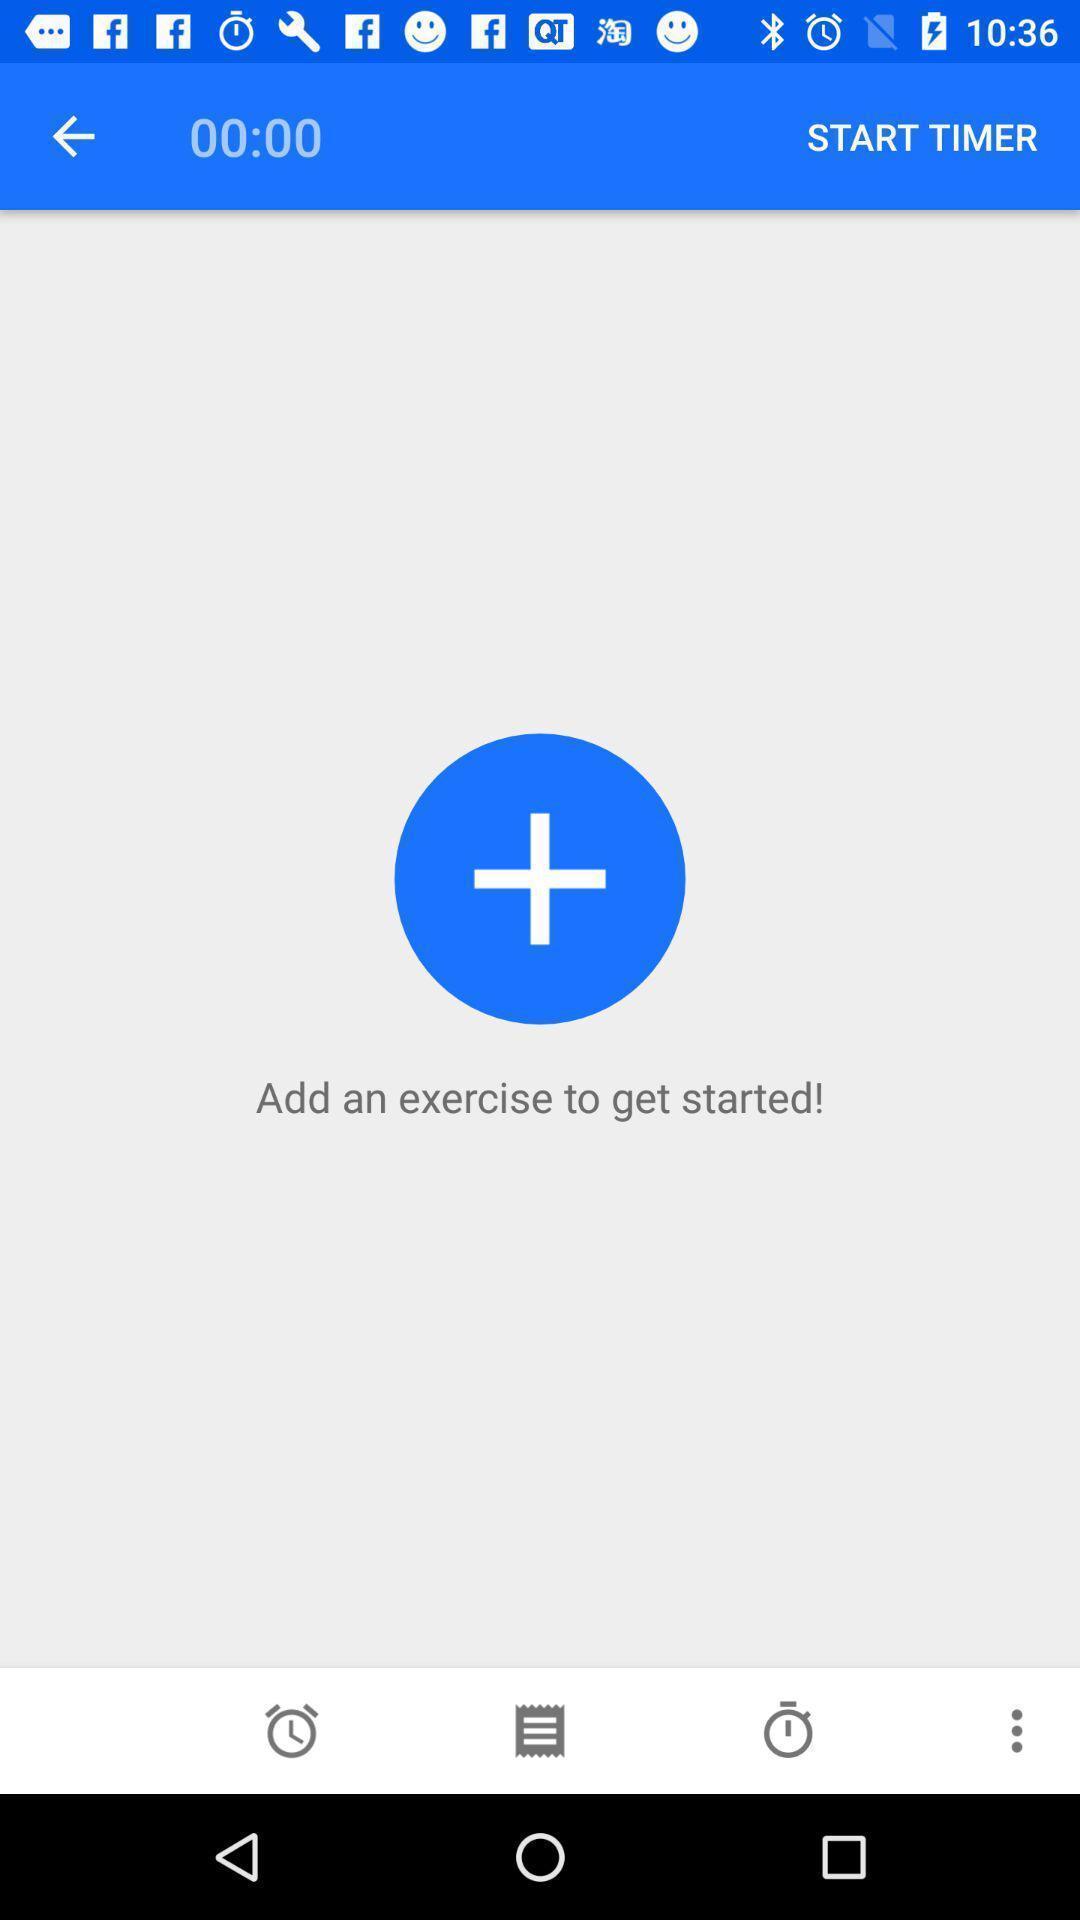Tell me what you see in this picture. Screen shows to add an exercise to get started. 